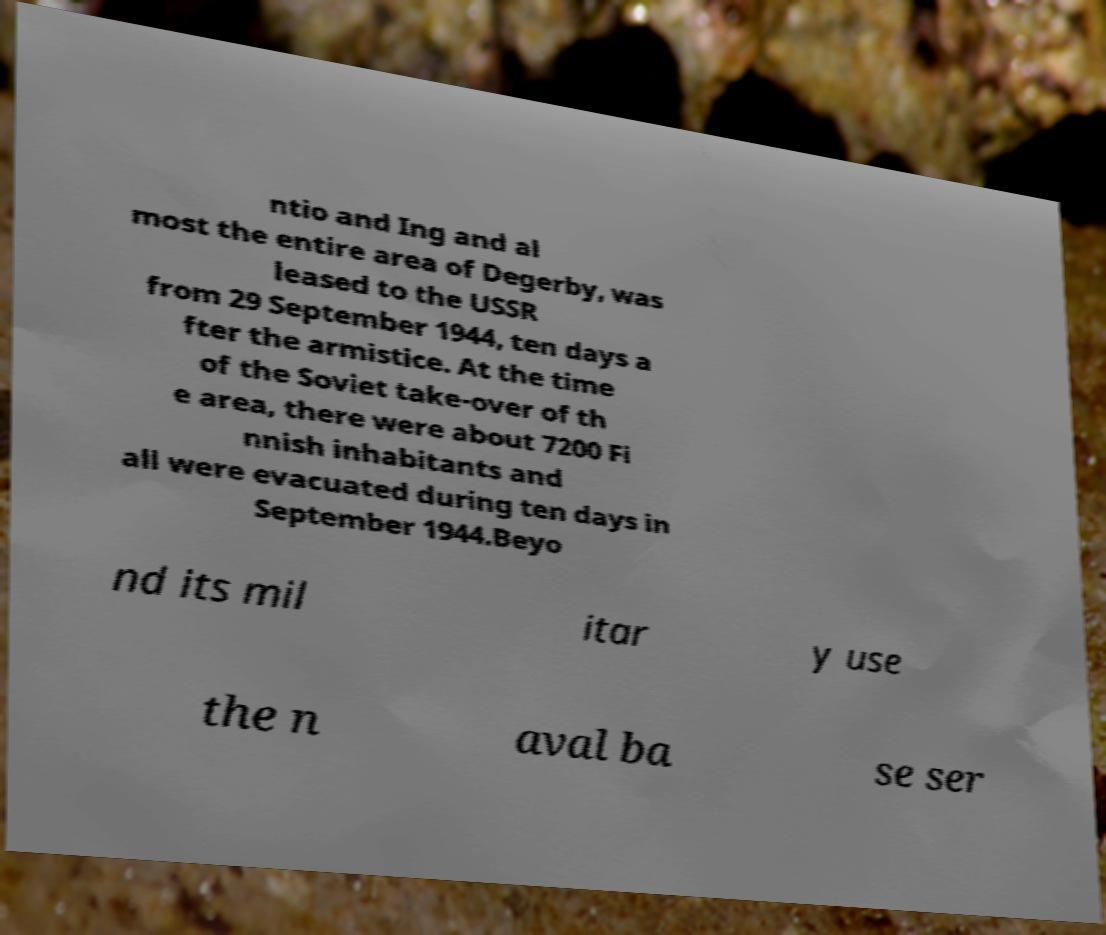Can you read and provide the text displayed in the image?This photo seems to have some interesting text. Can you extract and type it out for me? ntio and Ing and al most the entire area of Degerby, was leased to the USSR from 29 September 1944, ten days a fter the armistice. At the time of the Soviet take-over of th e area, there were about 7200 Fi nnish inhabitants and all were evacuated during ten days in September 1944.Beyo nd its mil itar y use the n aval ba se ser 